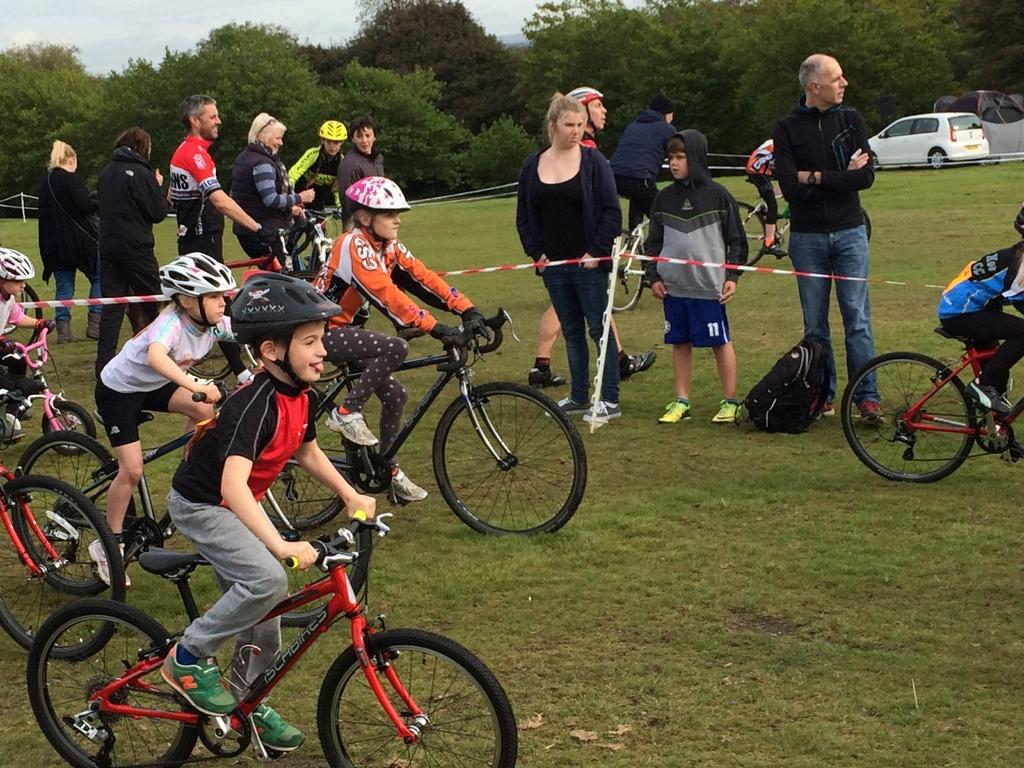What are the kids doing in the image? The kids are riding bicycles in the image. What else can be seen in the image besides the kids on bicycles? There are people standing in the image, and there is a bag present. What can be seen in the background of the image? In the background of the image, there is a car, trees, a fence, and the sky. What is at the bottom of the image? There is grass at the bottom of the image. What type of play is the achiever performing in the image? There is no achiever or play present in the image; it features kids riding bicycles and other elements mentioned in the facts. 